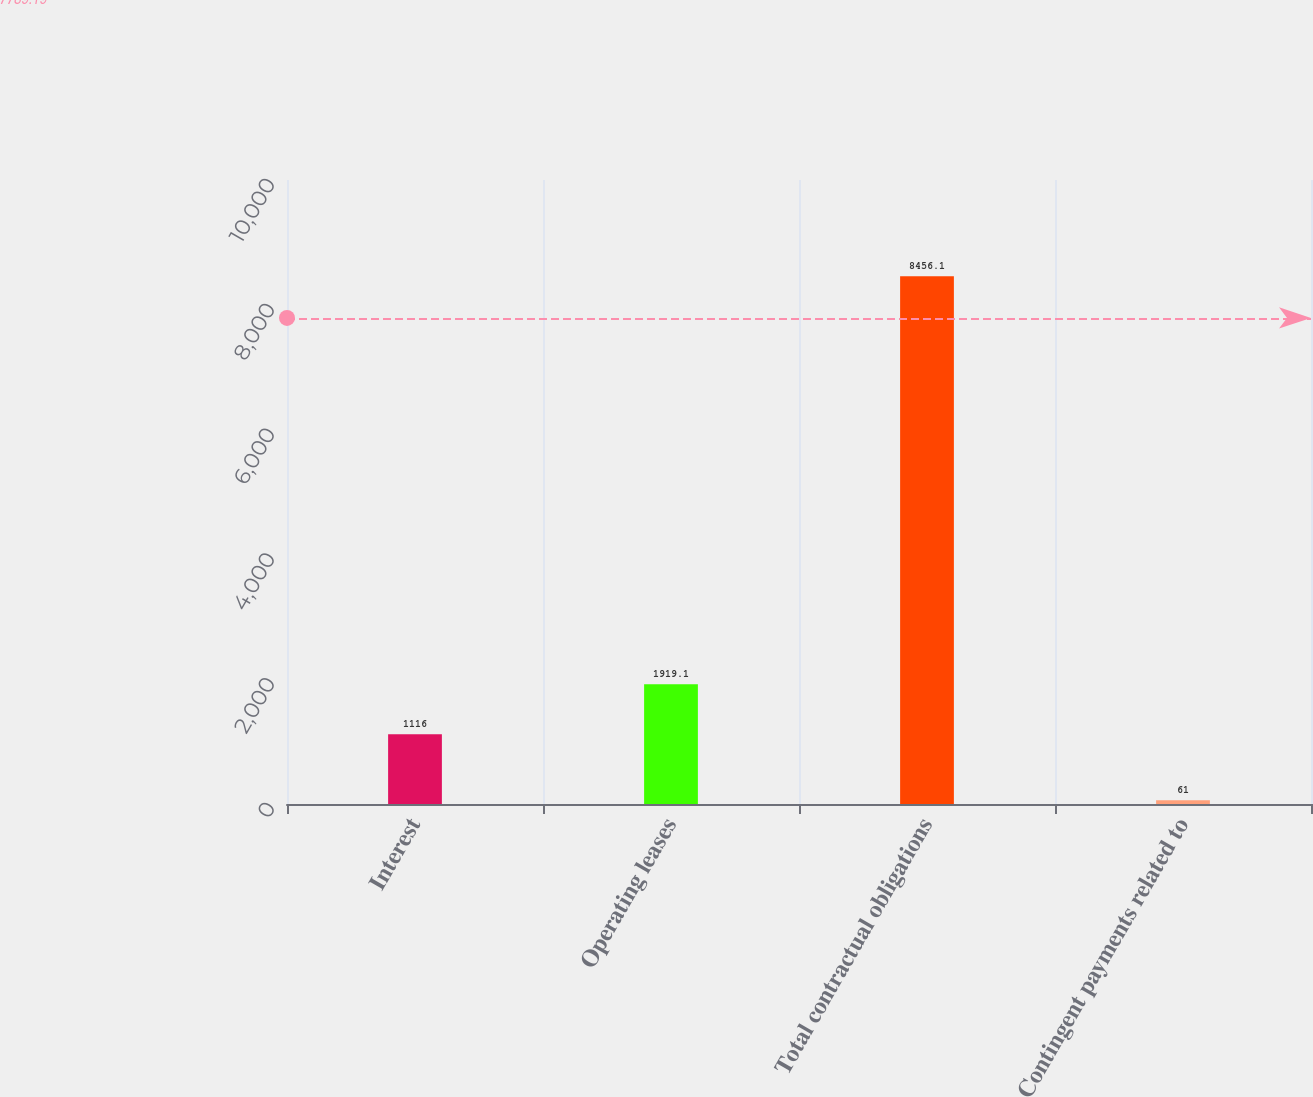<chart> <loc_0><loc_0><loc_500><loc_500><bar_chart><fcel>Interest<fcel>Operating leases<fcel>Total contractual obligations<fcel>Contingent payments related to<nl><fcel>1116<fcel>1919.1<fcel>8456.1<fcel>61<nl></chart> 